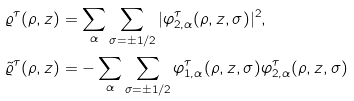<formula> <loc_0><loc_0><loc_500><loc_500>\varrho ^ { \tau } ( \rho , z ) & = \sum _ { \alpha } \sum _ { \sigma = \pm 1 / 2 } | \varphi _ { 2 , \alpha } ^ { \tau } ( \rho , z , \sigma ) | ^ { 2 } , \\ \tilde { \varrho } ^ { \tau } ( \rho , z ) & = - \sum _ { \alpha } \sum _ { \sigma = \pm 1 / 2 } \varphi _ { 1 , \alpha } ^ { \tau } ( \rho , z , \sigma ) \varphi _ { 2 , \alpha } ^ { \tau } ( \rho , z , \sigma )</formula> 